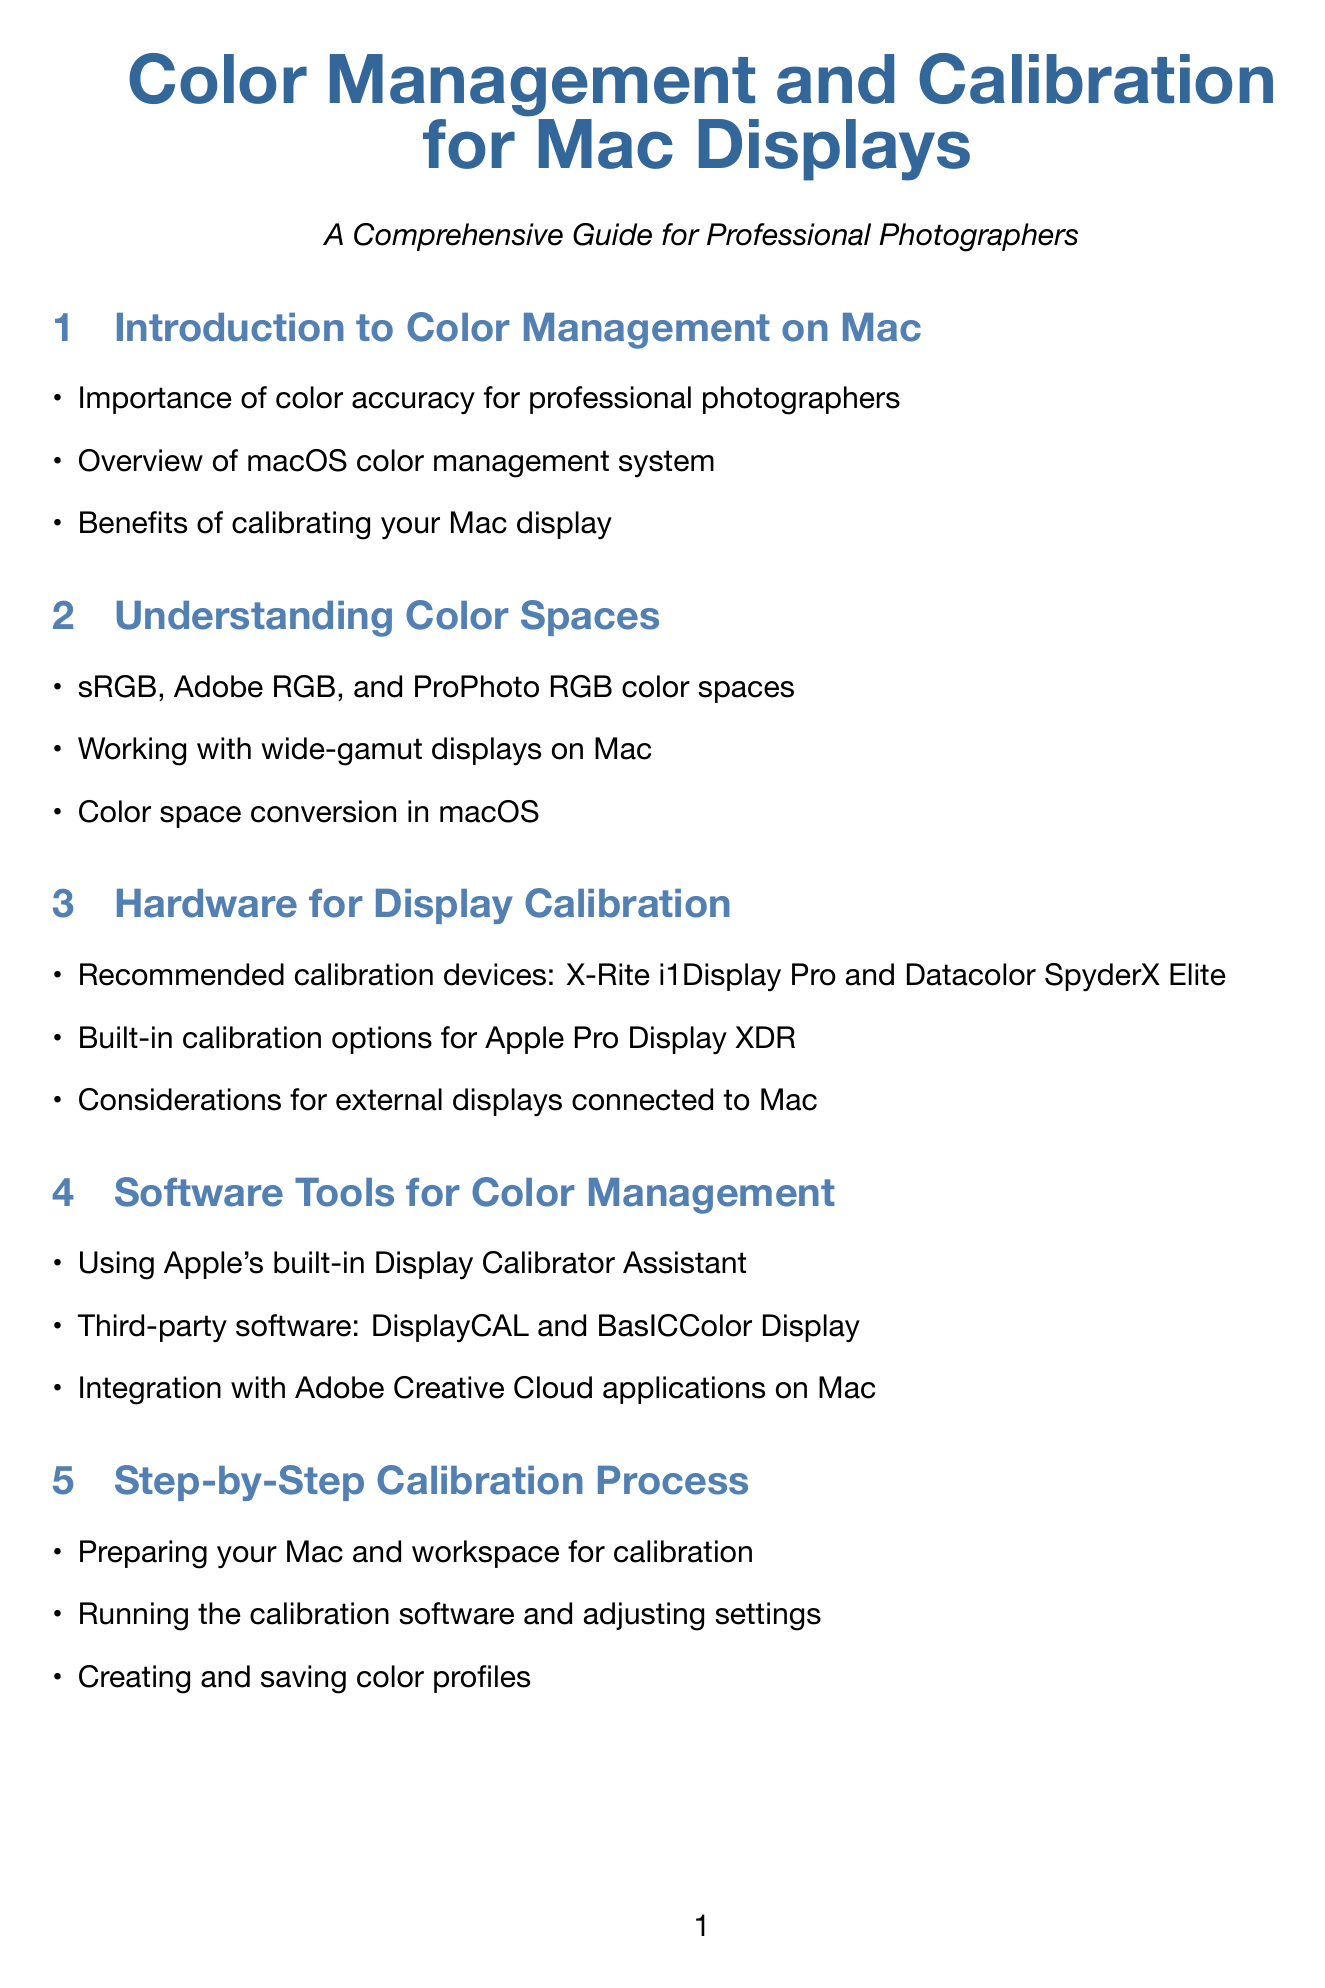What is the primary focus of color management for photographers? The manual emphasizes the importance of color accuracy for professional photographers.
Answer: Color accuracy What calibration devices are recommended? The manual lists X-Rite i1Display Pro and Datacolor SpyderX Elite as recommended calibration devices.
Answer: X-Rite i1Display Pro and Datacolor SpyderX Elite What software tools are mentioned for color management? The document mentions Apple's Display Calibrator Assistant, DisplayCAL, and BasICColor Display as software tools.
Answer: Display Calibrator Assistant, DisplayCAL, BasICColor Display How often should calibration be done? The manual provides a recommended calibration frequency for professional work, though it doesn't specify a number.
Answer: Recommended frequency What is soft proofing used for? The document describes soft proofing in the context of Adobe Photoshop and Lightroom on Mac.
Answer: Soft proofing Which color spaces are covered in the document? The manual outlines sRGB, Adobe RGB, and ProPhoto RGB as color spaces.
Answer: sRGB, Adobe RGB, ProPhoto RGB What environmental factors can affect color perception? The manual discusses environmental factors affecting color perception on Mac displays without specifying them.
Answer: Environmental factors What topic does the last section of the manual address? The last section focuses on the future of color management on Mac, including HDR and wide color gamut support.
Answer: Future of color management 